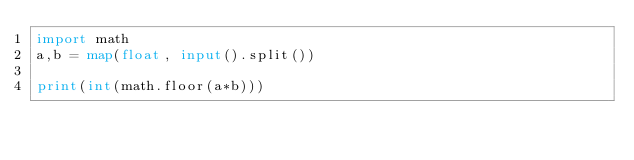<code> <loc_0><loc_0><loc_500><loc_500><_Python_>import math
a,b = map(float, input().split())

print(int(math.floor(a*b)))</code> 